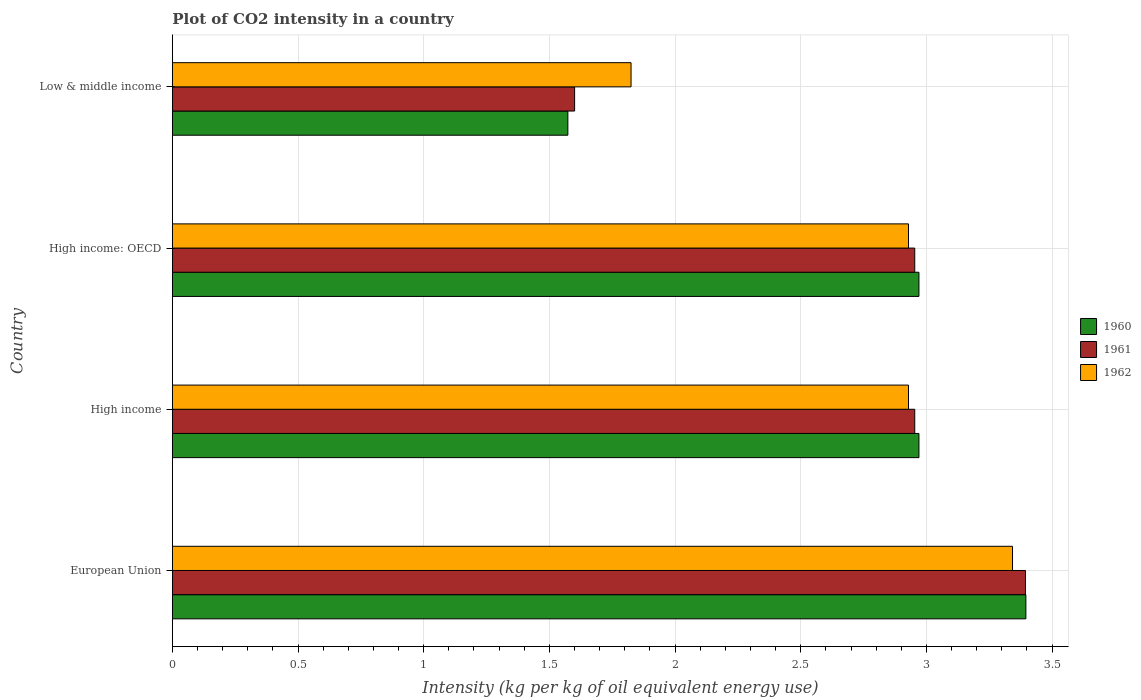How many different coloured bars are there?
Keep it short and to the point. 3. How many bars are there on the 2nd tick from the top?
Your answer should be compact. 3. How many bars are there on the 1st tick from the bottom?
Your answer should be compact. 3. What is the label of the 3rd group of bars from the top?
Keep it short and to the point. High income. What is the CO2 intensity in in 1962 in High income?
Keep it short and to the point. 2.93. Across all countries, what is the maximum CO2 intensity in in 1962?
Provide a short and direct response. 3.34. Across all countries, what is the minimum CO2 intensity in in 1960?
Keep it short and to the point. 1.57. In which country was the CO2 intensity in in 1962 maximum?
Your response must be concise. European Union. In which country was the CO2 intensity in in 1962 minimum?
Your response must be concise. Low & middle income. What is the total CO2 intensity in in 1962 in the graph?
Provide a succinct answer. 11.03. What is the difference between the CO2 intensity in in 1962 in High income and that in Low & middle income?
Give a very brief answer. 1.1. What is the difference between the CO2 intensity in in 1960 in High income: OECD and the CO2 intensity in in 1961 in Low & middle income?
Give a very brief answer. 1.37. What is the average CO2 intensity in in 1962 per country?
Keep it short and to the point. 2.76. What is the difference between the CO2 intensity in in 1962 and CO2 intensity in in 1960 in Low & middle income?
Provide a succinct answer. 0.25. What is the ratio of the CO2 intensity in in 1960 in High income to that in Low & middle income?
Provide a succinct answer. 1.89. Is the CO2 intensity in in 1961 in European Union less than that in High income: OECD?
Give a very brief answer. No. Is the difference between the CO2 intensity in in 1962 in European Union and Low & middle income greater than the difference between the CO2 intensity in in 1960 in European Union and Low & middle income?
Ensure brevity in your answer.  No. What is the difference between the highest and the second highest CO2 intensity in in 1961?
Make the answer very short. 0.44. What is the difference between the highest and the lowest CO2 intensity in in 1961?
Your answer should be very brief. 1.79. Is it the case that in every country, the sum of the CO2 intensity in in 1961 and CO2 intensity in in 1962 is greater than the CO2 intensity in in 1960?
Your response must be concise. Yes. How many bars are there?
Your answer should be compact. 12. What is the difference between two consecutive major ticks on the X-axis?
Make the answer very short. 0.5. Are the values on the major ticks of X-axis written in scientific E-notation?
Provide a succinct answer. No. Does the graph contain grids?
Offer a very short reply. Yes. How are the legend labels stacked?
Your answer should be very brief. Vertical. What is the title of the graph?
Make the answer very short. Plot of CO2 intensity in a country. What is the label or title of the X-axis?
Provide a short and direct response. Intensity (kg per kg of oil equivalent energy use). What is the Intensity (kg per kg of oil equivalent energy use) in 1960 in European Union?
Your answer should be very brief. 3.4. What is the Intensity (kg per kg of oil equivalent energy use) in 1961 in European Union?
Your answer should be very brief. 3.39. What is the Intensity (kg per kg of oil equivalent energy use) of 1962 in European Union?
Your answer should be compact. 3.34. What is the Intensity (kg per kg of oil equivalent energy use) in 1960 in High income?
Keep it short and to the point. 2.97. What is the Intensity (kg per kg of oil equivalent energy use) in 1961 in High income?
Offer a very short reply. 2.95. What is the Intensity (kg per kg of oil equivalent energy use) of 1962 in High income?
Give a very brief answer. 2.93. What is the Intensity (kg per kg of oil equivalent energy use) of 1960 in High income: OECD?
Provide a succinct answer. 2.97. What is the Intensity (kg per kg of oil equivalent energy use) of 1961 in High income: OECD?
Give a very brief answer. 2.95. What is the Intensity (kg per kg of oil equivalent energy use) in 1962 in High income: OECD?
Provide a short and direct response. 2.93. What is the Intensity (kg per kg of oil equivalent energy use) in 1960 in Low & middle income?
Provide a succinct answer. 1.57. What is the Intensity (kg per kg of oil equivalent energy use) of 1961 in Low & middle income?
Keep it short and to the point. 1.6. What is the Intensity (kg per kg of oil equivalent energy use) in 1962 in Low & middle income?
Your answer should be very brief. 1.82. Across all countries, what is the maximum Intensity (kg per kg of oil equivalent energy use) in 1960?
Ensure brevity in your answer.  3.4. Across all countries, what is the maximum Intensity (kg per kg of oil equivalent energy use) in 1961?
Your answer should be compact. 3.39. Across all countries, what is the maximum Intensity (kg per kg of oil equivalent energy use) of 1962?
Your response must be concise. 3.34. Across all countries, what is the minimum Intensity (kg per kg of oil equivalent energy use) of 1960?
Provide a succinct answer. 1.57. Across all countries, what is the minimum Intensity (kg per kg of oil equivalent energy use) of 1961?
Provide a short and direct response. 1.6. Across all countries, what is the minimum Intensity (kg per kg of oil equivalent energy use) in 1962?
Your answer should be very brief. 1.82. What is the total Intensity (kg per kg of oil equivalent energy use) of 1960 in the graph?
Offer a very short reply. 10.91. What is the total Intensity (kg per kg of oil equivalent energy use) of 1961 in the graph?
Provide a short and direct response. 10.9. What is the total Intensity (kg per kg of oil equivalent energy use) of 1962 in the graph?
Offer a very short reply. 11.03. What is the difference between the Intensity (kg per kg of oil equivalent energy use) in 1960 in European Union and that in High income?
Offer a very short reply. 0.43. What is the difference between the Intensity (kg per kg of oil equivalent energy use) of 1961 in European Union and that in High income?
Offer a terse response. 0.44. What is the difference between the Intensity (kg per kg of oil equivalent energy use) in 1962 in European Union and that in High income?
Your response must be concise. 0.41. What is the difference between the Intensity (kg per kg of oil equivalent energy use) in 1960 in European Union and that in High income: OECD?
Ensure brevity in your answer.  0.43. What is the difference between the Intensity (kg per kg of oil equivalent energy use) in 1961 in European Union and that in High income: OECD?
Your response must be concise. 0.44. What is the difference between the Intensity (kg per kg of oil equivalent energy use) of 1962 in European Union and that in High income: OECD?
Keep it short and to the point. 0.41. What is the difference between the Intensity (kg per kg of oil equivalent energy use) of 1960 in European Union and that in Low & middle income?
Provide a succinct answer. 1.82. What is the difference between the Intensity (kg per kg of oil equivalent energy use) of 1961 in European Union and that in Low & middle income?
Provide a succinct answer. 1.79. What is the difference between the Intensity (kg per kg of oil equivalent energy use) in 1962 in European Union and that in Low & middle income?
Give a very brief answer. 1.52. What is the difference between the Intensity (kg per kg of oil equivalent energy use) of 1961 in High income and that in High income: OECD?
Provide a succinct answer. 0. What is the difference between the Intensity (kg per kg of oil equivalent energy use) in 1960 in High income and that in Low & middle income?
Your response must be concise. 1.4. What is the difference between the Intensity (kg per kg of oil equivalent energy use) of 1961 in High income and that in Low & middle income?
Keep it short and to the point. 1.35. What is the difference between the Intensity (kg per kg of oil equivalent energy use) in 1962 in High income and that in Low & middle income?
Your answer should be very brief. 1.1. What is the difference between the Intensity (kg per kg of oil equivalent energy use) of 1960 in High income: OECD and that in Low & middle income?
Offer a very short reply. 1.4. What is the difference between the Intensity (kg per kg of oil equivalent energy use) in 1961 in High income: OECD and that in Low & middle income?
Your response must be concise. 1.35. What is the difference between the Intensity (kg per kg of oil equivalent energy use) of 1962 in High income: OECD and that in Low & middle income?
Give a very brief answer. 1.1. What is the difference between the Intensity (kg per kg of oil equivalent energy use) in 1960 in European Union and the Intensity (kg per kg of oil equivalent energy use) in 1961 in High income?
Give a very brief answer. 0.44. What is the difference between the Intensity (kg per kg of oil equivalent energy use) of 1960 in European Union and the Intensity (kg per kg of oil equivalent energy use) of 1962 in High income?
Offer a very short reply. 0.47. What is the difference between the Intensity (kg per kg of oil equivalent energy use) in 1961 in European Union and the Intensity (kg per kg of oil equivalent energy use) in 1962 in High income?
Offer a terse response. 0.47. What is the difference between the Intensity (kg per kg of oil equivalent energy use) of 1960 in European Union and the Intensity (kg per kg of oil equivalent energy use) of 1961 in High income: OECD?
Provide a succinct answer. 0.44. What is the difference between the Intensity (kg per kg of oil equivalent energy use) in 1960 in European Union and the Intensity (kg per kg of oil equivalent energy use) in 1962 in High income: OECD?
Give a very brief answer. 0.47. What is the difference between the Intensity (kg per kg of oil equivalent energy use) of 1961 in European Union and the Intensity (kg per kg of oil equivalent energy use) of 1962 in High income: OECD?
Give a very brief answer. 0.47. What is the difference between the Intensity (kg per kg of oil equivalent energy use) of 1960 in European Union and the Intensity (kg per kg of oil equivalent energy use) of 1961 in Low & middle income?
Keep it short and to the point. 1.8. What is the difference between the Intensity (kg per kg of oil equivalent energy use) in 1960 in European Union and the Intensity (kg per kg of oil equivalent energy use) in 1962 in Low & middle income?
Give a very brief answer. 1.57. What is the difference between the Intensity (kg per kg of oil equivalent energy use) in 1961 in European Union and the Intensity (kg per kg of oil equivalent energy use) in 1962 in Low & middle income?
Offer a terse response. 1.57. What is the difference between the Intensity (kg per kg of oil equivalent energy use) in 1960 in High income and the Intensity (kg per kg of oil equivalent energy use) in 1961 in High income: OECD?
Your answer should be very brief. 0.02. What is the difference between the Intensity (kg per kg of oil equivalent energy use) in 1960 in High income and the Intensity (kg per kg of oil equivalent energy use) in 1962 in High income: OECD?
Your answer should be very brief. 0.04. What is the difference between the Intensity (kg per kg of oil equivalent energy use) in 1961 in High income and the Intensity (kg per kg of oil equivalent energy use) in 1962 in High income: OECD?
Ensure brevity in your answer.  0.02. What is the difference between the Intensity (kg per kg of oil equivalent energy use) of 1960 in High income and the Intensity (kg per kg of oil equivalent energy use) of 1961 in Low & middle income?
Your answer should be very brief. 1.37. What is the difference between the Intensity (kg per kg of oil equivalent energy use) in 1960 in High income and the Intensity (kg per kg of oil equivalent energy use) in 1962 in Low & middle income?
Ensure brevity in your answer.  1.15. What is the difference between the Intensity (kg per kg of oil equivalent energy use) of 1961 in High income and the Intensity (kg per kg of oil equivalent energy use) of 1962 in Low & middle income?
Your answer should be very brief. 1.13. What is the difference between the Intensity (kg per kg of oil equivalent energy use) of 1960 in High income: OECD and the Intensity (kg per kg of oil equivalent energy use) of 1961 in Low & middle income?
Ensure brevity in your answer.  1.37. What is the difference between the Intensity (kg per kg of oil equivalent energy use) in 1960 in High income: OECD and the Intensity (kg per kg of oil equivalent energy use) in 1962 in Low & middle income?
Provide a short and direct response. 1.15. What is the difference between the Intensity (kg per kg of oil equivalent energy use) in 1961 in High income: OECD and the Intensity (kg per kg of oil equivalent energy use) in 1962 in Low & middle income?
Make the answer very short. 1.13. What is the average Intensity (kg per kg of oil equivalent energy use) of 1960 per country?
Provide a short and direct response. 2.73. What is the average Intensity (kg per kg of oil equivalent energy use) in 1961 per country?
Your response must be concise. 2.73. What is the average Intensity (kg per kg of oil equivalent energy use) of 1962 per country?
Offer a terse response. 2.76. What is the difference between the Intensity (kg per kg of oil equivalent energy use) of 1960 and Intensity (kg per kg of oil equivalent energy use) of 1961 in European Union?
Make the answer very short. 0. What is the difference between the Intensity (kg per kg of oil equivalent energy use) of 1960 and Intensity (kg per kg of oil equivalent energy use) of 1962 in European Union?
Ensure brevity in your answer.  0.05. What is the difference between the Intensity (kg per kg of oil equivalent energy use) in 1961 and Intensity (kg per kg of oil equivalent energy use) in 1962 in European Union?
Give a very brief answer. 0.05. What is the difference between the Intensity (kg per kg of oil equivalent energy use) of 1960 and Intensity (kg per kg of oil equivalent energy use) of 1961 in High income?
Your answer should be very brief. 0.02. What is the difference between the Intensity (kg per kg of oil equivalent energy use) of 1960 and Intensity (kg per kg of oil equivalent energy use) of 1962 in High income?
Offer a terse response. 0.04. What is the difference between the Intensity (kg per kg of oil equivalent energy use) of 1961 and Intensity (kg per kg of oil equivalent energy use) of 1962 in High income?
Provide a short and direct response. 0.02. What is the difference between the Intensity (kg per kg of oil equivalent energy use) of 1960 and Intensity (kg per kg of oil equivalent energy use) of 1961 in High income: OECD?
Provide a succinct answer. 0.02. What is the difference between the Intensity (kg per kg of oil equivalent energy use) in 1960 and Intensity (kg per kg of oil equivalent energy use) in 1962 in High income: OECD?
Your answer should be compact. 0.04. What is the difference between the Intensity (kg per kg of oil equivalent energy use) in 1961 and Intensity (kg per kg of oil equivalent energy use) in 1962 in High income: OECD?
Ensure brevity in your answer.  0.02. What is the difference between the Intensity (kg per kg of oil equivalent energy use) of 1960 and Intensity (kg per kg of oil equivalent energy use) of 1961 in Low & middle income?
Provide a short and direct response. -0.03. What is the difference between the Intensity (kg per kg of oil equivalent energy use) in 1960 and Intensity (kg per kg of oil equivalent energy use) in 1962 in Low & middle income?
Ensure brevity in your answer.  -0.25. What is the difference between the Intensity (kg per kg of oil equivalent energy use) of 1961 and Intensity (kg per kg of oil equivalent energy use) of 1962 in Low & middle income?
Offer a very short reply. -0.22. What is the ratio of the Intensity (kg per kg of oil equivalent energy use) of 1960 in European Union to that in High income?
Provide a succinct answer. 1.14. What is the ratio of the Intensity (kg per kg of oil equivalent energy use) of 1961 in European Union to that in High income?
Offer a terse response. 1.15. What is the ratio of the Intensity (kg per kg of oil equivalent energy use) of 1962 in European Union to that in High income?
Your answer should be very brief. 1.14. What is the ratio of the Intensity (kg per kg of oil equivalent energy use) in 1960 in European Union to that in High income: OECD?
Your response must be concise. 1.14. What is the ratio of the Intensity (kg per kg of oil equivalent energy use) in 1961 in European Union to that in High income: OECD?
Keep it short and to the point. 1.15. What is the ratio of the Intensity (kg per kg of oil equivalent energy use) in 1962 in European Union to that in High income: OECD?
Your answer should be very brief. 1.14. What is the ratio of the Intensity (kg per kg of oil equivalent energy use) in 1960 in European Union to that in Low & middle income?
Your answer should be compact. 2.16. What is the ratio of the Intensity (kg per kg of oil equivalent energy use) of 1961 in European Union to that in Low & middle income?
Offer a very short reply. 2.12. What is the ratio of the Intensity (kg per kg of oil equivalent energy use) of 1962 in European Union to that in Low & middle income?
Provide a succinct answer. 1.83. What is the ratio of the Intensity (kg per kg of oil equivalent energy use) of 1960 in High income to that in High income: OECD?
Your answer should be very brief. 1. What is the ratio of the Intensity (kg per kg of oil equivalent energy use) in 1961 in High income to that in High income: OECD?
Keep it short and to the point. 1. What is the ratio of the Intensity (kg per kg of oil equivalent energy use) in 1962 in High income to that in High income: OECD?
Make the answer very short. 1. What is the ratio of the Intensity (kg per kg of oil equivalent energy use) of 1960 in High income to that in Low & middle income?
Your answer should be compact. 1.89. What is the ratio of the Intensity (kg per kg of oil equivalent energy use) in 1961 in High income to that in Low & middle income?
Provide a short and direct response. 1.85. What is the ratio of the Intensity (kg per kg of oil equivalent energy use) of 1962 in High income to that in Low & middle income?
Provide a short and direct response. 1.6. What is the ratio of the Intensity (kg per kg of oil equivalent energy use) of 1960 in High income: OECD to that in Low & middle income?
Your response must be concise. 1.89. What is the ratio of the Intensity (kg per kg of oil equivalent energy use) in 1961 in High income: OECD to that in Low & middle income?
Ensure brevity in your answer.  1.85. What is the ratio of the Intensity (kg per kg of oil equivalent energy use) in 1962 in High income: OECD to that in Low & middle income?
Make the answer very short. 1.6. What is the difference between the highest and the second highest Intensity (kg per kg of oil equivalent energy use) in 1960?
Offer a terse response. 0.43. What is the difference between the highest and the second highest Intensity (kg per kg of oil equivalent energy use) of 1961?
Offer a terse response. 0.44. What is the difference between the highest and the second highest Intensity (kg per kg of oil equivalent energy use) in 1962?
Offer a very short reply. 0.41. What is the difference between the highest and the lowest Intensity (kg per kg of oil equivalent energy use) of 1960?
Provide a succinct answer. 1.82. What is the difference between the highest and the lowest Intensity (kg per kg of oil equivalent energy use) of 1961?
Offer a terse response. 1.79. What is the difference between the highest and the lowest Intensity (kg per kg of oil equivalent energy use) in 1962?
Make the answer very short. 1.52. 